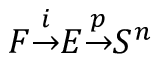Convert formula to latex. <formula><loc_0><loc_0><loc_500><loc_500>F { \overset { i } { \to } } E { \overset { p } { \to } } S ^ { n }</formula> 